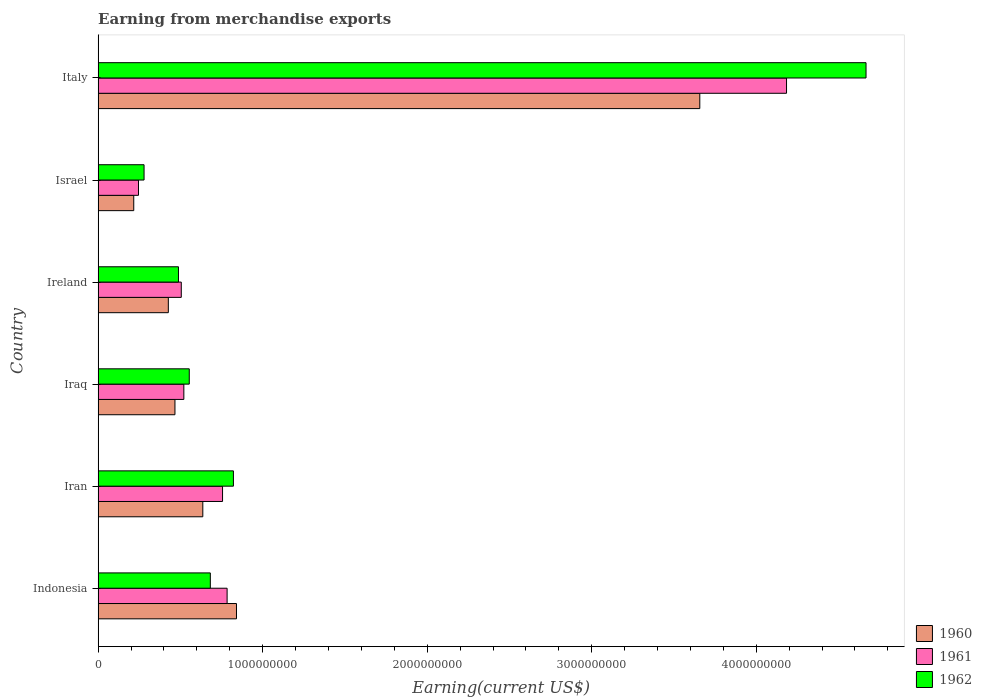How many different coloured bars are there?
Give a very brief answer. 3. How many groups of bars are there?
Your response must be concise. 6. Are the number of bars per tick equal to the number of legend labels?
Provide a succinct answer. Yes. How many bars are there on the 5th tick from the top?
Your answer should be compact. 3. What is the label of the 3rd group of bars from the top?
Keep it short and to the point. Ireland. What is the amount earned from merchandise exports in 1960 in Iran?
Ensure brevity in your answer.  6.36e+08. Across all countries, what is the maximum amount earned from merchandise exports in 1961?
Offer a very short reply. 4.18e+09. Across all countries, what is the minimum amount earned from merchandise exports in 1960?
Give a very brief answer. 2.17e+08. In which country was the amount earned from merchandise exports in 1960 maximum?
Provide a short and direct response. Italy. In which country was the amount earned from merchandise exports in 1962 minimum?
Give a very brief answer. Israel. What is the total amount earned from merchandise exports in 1962 in the graph?
Offer a very short reply. 7.49e+09. What is the difference between the amount earned from merchandise exports in 1962 in Indonesia and that in Israel?
Offer a terse response. 4.03e+08. What is the difference between the amount earned from merchandise exports in 1962 in Iraq and the amount earned from merchandise exports in 1961 in Iran?
Keep it short and to the point. -2.02e+08. What is the average amount earned from merchandise exports in 1961 per country?
Offer a very short reply. 1.17e+09. What is the difference between the amount earned from merchandise exports in 1961 and amount earned from merchandise exports in 1962 in Israel?
Offer a very short reply. -3.39e+07. What is the ratio of the amount earned from merchandise exports in 1960 in Ireland to that in Israel?
Your response must be concise. 1.97. Is the amount earned from merchandise exports in 1960 in Iran less than that in Ireland?
Offer a terse response. No. What is the difference between the highest and the second highest amount earned from merchandise exports in 1962?
Provide a short and direct response. 3.84e+09. What is the difference between the highest and the lowest amount earned from merchandise exports in 1961?
Offer a very short reply. 3.94e+09. In how many countries, is the amount earned from merchandise exports in 1960 greater than the average amount earned from merchandise exports in 1960 taken over all countries?
Provide a succinct answer. 1. What does the 3rd bar from the top in Iraq represents?
Give a very brief answer. 1960. Is it the case that in every country, the sum of the amount earned from merchandise exports in 1961 and amount earned from merchandise exports in 1960 is greater than the amount earned from merchandise exports in 1962?
Offer a very short reply. Yes. How many bars are there?
Ensure brevity in your answer.  18. What is the difference between two consecutive major ticks on the X-axis?
Your answer should be very brief. 1.00e+09. Does the graph contain any zero values?
Keep it short and to the point. No. What is the title of the graph?
Give a very brief answer. Earning from merchandise exports. Does "2002" appear as one of the legend labels in the graph?
Give a very brief answer. No. What is the label or title of the X-axis?
Keep it short and to the point. Earning(current US$). What is the label or title of the Y-axis?
Make the answer very short. Country. What is the Earning(current US$) in 1960 in Indonesia?
Offer a very short reply. 8.41e+08. What is the Earning(current US$) in 1961 in Indonesia?
Your response must be concise. 7.84e+08. What is the Earning(current US$) of 1962 in Indonesia?
Your answer should be very brief. 6.82e+08. What is the Earning(current US$) in 1960 in Iran?
Your response must be concise. 6.36e+08. What is the Earning(current US$) in 1961 in Iran?
Keep it short and to the point. 7.56e+08. What is the Earning(current US$) in 1962 in Iran?
Your response must be concise. 8.22e+08. What is the Earning(current US$) of 1960 in Iraq?
Make the answer very short. 4.67e+08. What is the Earning(current US$) of 1961 in Iraq?
Give a very brief answer. 5.21e+08. What is the Earning(current US$) of 1962 in Iraq?
Ensure brevity in your answer.  5.54e+08. What is the Earning(current US$) in 1960 in Ireland?
Provide a succinct answer. 4.27e+08. What is the Earning(current US$) of 1961 in Ireland?
Offer a very short reply. 5.05e+08. What is the Earning(current US$) of 1962 in Ireland?
Your response must be concise. 4.88e+08. What is the Earning(current US$) in 1960 in Israel?
Your answer should be very brief. 2.17e+08. What is the Earning(current US$) in 1961 in Israel?
Your answer should be compact. 2.45e+08. What is the Earning(current US$) in 1962 in Israel?
Ensure brevity in your answer.  2.79e+08. What is the Earning(current US$) of 1960 in Italy?
Your answer should be compact. 3.66e+09. What is the Earning(current US$) in 1961 in Italy?
Provide a succinct answer. 4.18e+09. What is the Earning(current US$) in 1962 in Italy?
Offer a very short reply. 4.67e+09. Across all countries, what is the maximum Earning(current US$) of 1960?
Offer a very short reply. 3.66e+09. Across all countries, what is the maximum Earning(current US$) of 1961?
Provide a succinct answer. 4.18e+09. Across all countries, what is the maximum Earning(current US$) of 1962?
Offer a very short reply. 4.67e+09. Across all countries, what is the minimum Earning(current US$) in 1960?
Make the answer very short. 2.17e+08. Across all countries, what is the minimum Earning(current US$) in 1961?
Give a very brief answer. 2.45e+08. Across all countries, what is the minimum Earning(current US$) in 1962?
Provide a short and direct response. 2.79e+08. What is the total Earning(current US$) of 1960 in the graph?
Provide a short and direct response. 6.24e+09. What is the total Earning(current US$) of 1961 in the graph?
Offer a very short reply. 7.00e+09. What is the total Earning(current US$) of 1962 in the graph?
Provide a succinct answer. 7.49e+09. What is the difference between the Earning(current US$) in 1960 in Indonesia and that in Iran?
Make the answer very short. 2.05e+08. What is the difference between the Earning(current US$) of 1961 in Indonesia and that in Iran?
Give a very brief answer. 2.77e+07. What is the difference between the Earning(current US$) in 1962 in Indonesia and that in Iran?
Provide a short and direct response. -1.40e+08. What is the difference between the Earning(current US$) of 1960 in Indonesia and that in Iraq?
Provide a short and direct response. 3.74e+08. What is the difference between the Earning(current US$) of 1961 in Indonesia and that in Iraq?
Provide a short and direct response. 2.63e+08. What is the difference between the Earning(current US$) in 1962 in Indonesia and that in Iraq?
Give a very brief answer. 1.28e+08. What is the difference between the Earning(current US$) of 1960 in Indonesia and that in Ireland?
Ensure brevity in your answer.  4.14e+08. What is the difference between the Earning(current US$) of 1961 in Indonesia and that in Ireland?
Make the answer very short. 2.79e+08. What is the difference between the Earning(current US$) of 1962 in Indonesia and that in Ireland?
Your answer should be compact. 1.94e+08. What is the difference between the Earning(current US$) in 1960 in Indonesia and that in Israel?
Make the answer very short. 6.24e+08. What is the difference between the Earning(current US$) in 1961 in Indonesia and that in Israel?
Provide a short and direct response. 5.39e+08. What is the difference between the Earning(current US$) in 1962 in Indonesia and that in Israel?
Your answer should be very brief. 4.03e+08. What is the difference between the Earning(current US$) of 1960 in Indonesia and that in Italy?
Make the answer very short. -2.82e+09. What is the difference between the Earning(current US$) of 1961 in Indonesia and that in Italy?
Offer a very short reply. -3.40e+09. What is the difference between the Earning(current US$) of 1962 in Indonesia and that in Italy?
Your response must be concise. -3.99e+09. What is the difference between the Earning(current US$) in 1960 in Iran and that in Iraq?
Your response must be concise. 1.69e+08. What is the difference between the Earning(current US$) of 1961 in Iran and that in Iraq?
Provide a succinct answer. 2.35e+08. What is the difference between the Earning(current US$) of 1962 in Iran and that in Iraq?
Make the answer very short. 2.68e+08. What is the difference between the Earning(current US$) of 1960 in Iran and that in Ireland?
Provide a short and direct response. 2.10e+08. What is the difference between the Earning(current US$) of 1961 in Iran and that in Ireland?
Your answer should be very brief. 2.51e+08. What is the difference between the Earning(current US$) of 1962 in Iran and that in Ireland?
Offer a very short reply. 3.34e+08. What is the difference between the Earning(current US$) in 1960 in Iran and that in Israel?
Your answer should be very brief. 4.20e+08. What is the difference between the Earning(current US$) of 1961 in Iran and that in Israel?
Give a very brief answer. 5.11e+08. What is the difference between the Earning(current US$) of 1962 in Iran and that in Israel?
Your response must be concise. 5.43e+08. What is the difference between the Earning(current US$) of 1960 in Iran and that in Italy?
Provide a succinct answer. -3.02e+09. What is the difference between the Earning(current US$) in 1961 in Iran and that in Italy?
Make the answer very short. -3.43e+09. What is the difference between the Earning(current US$) in 1962 in Iran and that in Italy?
Your answer should be compact. -3.84e+09. What is the difference between the Earning(current US$) in 1960 in Iraq and that in Ireland?
Ensure brevity in your answer.  4.03e+07. What is the difference between the Earning(current US$) in 1961 in Iraq and that in Ireland?
Give a very brief answer. 1.56e+07. What is the difference between the Earning(current US$) of 1962 in Iraq and that in Ireland?
Offer a terse response. 6.57e+07. What is the difference between the Earning(current US$) of 1960 in Iraq and that in Israel?
Your response must be concise. 2.50e+08. What is the difference between the Earning(current US$) of 1961 in Iraq and that in Israel?
Make the answer very short. 2.76e+08. What is the difference between the Earning(current US$) in 1962 in Iraq and that in Israel?
Your response must be concise. 2.75e+08. What is the difference between the Earning(current US$) in 1960 in Iraq and that in Italy?
Provide a short and direct response. -3.19e+09. What is the difference between the Earning(current US$) of 1961 in Iraq and that in Italy?
Your response must be concise. -3.66e+09. What is the difference between the Earning(current US$) of 1962 in Iraq and that in Italy?
Your answer should be compact. -4.11e+09. What is the difference between the Earning(current US$) of 1960 in Ireland and that in Israel?
Ensure brevity in your answer.  2.10e+08. What is the difference between the Earning(current US$) in 1961 in Ireland and that in Israel?
Keep it short and to the point. 2.60e+08. What is the difference between the Earning(current US$) in 1962 in Ireland and that in Israel?
Provide a succinct answer. 2.09e+08. What is the difference between the Earning(current US$) of 1960 in Ireland and that in Italy?
Keep it short and to the point. -3.23e+09. What is the difference between the Earning(current US$) of 1961 in Ireland and that in Italy?
Your response must be concise. -3.68e+09. What is the difference between the Earning(current US$) in 1962 in Ireland and that in Italy?
Ensure brevity in your answer.  -4.18e+09. What is the difference between the Earning(current US$) of 1960 in Israel and that in Italy?
Provide a succinct answer. -3.44e+09. What is the difference between the Earning(current US$) in 1961 in Israel and that in Italy?
Offer a terse response. -3.94e+09. What is the difference between the Earning(current US$) of 1962 in Israel and that in Italy?
Provide a short and direct response. -4.39e+09. What is the difference between the Earning(current US$) of 1960 in Indonesia and the Earning(current US$) of 1961 in Iran?
Provide a short and direct response. 8.47e+07. What is the difference between the Earning(current US$) of 1960 in Indonesia and the Earning(current US$) of 1962 in Iran?
Provide a succinct answer. 1.86e+07. What is the difference between the Earning(current US$) of 1961 in Indonesia and the Earning(current US$) of 1962 in Iran?
Your answer should be compact. -3.84e+07. What is the difference between the Earning(current US$) in 1960 in Indonesia and the Earning(current US$) in 1961 in Iraq?
Offer a terse response. 3.20e+08. What is the difference between the Earning(current US$) of 1960 in Indonesia and the Earning(current US$) of 1962 in Iraq?
Keep it short and to the point. 2.87e+08. What is the difference between the Earning(current US$) in 1961 in Indonesia and the Earning(current US$) in 1962 in Iraq?
Offer a very short reply. 2.30e+08. What is the difference between the Earning(current US$) in 1960 in Indonesia and the Earning(current US$) in 1961 in Ireland?
Offer a very short reply. 3.36e+08. What is the difference between the Earning(current US$) of 1960 in Indonesia and the Earning(current US$) of 1962 in Ireland?
Your answer should be very brief. 3.53e+08. What is the difference between the Earning(current US$) of 1961 in Indonesia and the Earning(current US$) of 1962 in Ireland?
Provide a short and direct response. 2.96e+08. What is the difference between the Earning(current US$) in 1960 in Indonesia and the Earning(current US$) in 1961 in Israel?
Ensure brevity in your answer.  5.96e+08. What is the difference between the Earning(current US$) of 1960 in Indonesia and the Earning(current US$) of 1962 in Israel?
Provide a short and direct response. 5.62e+08. What is the difference between the Earning(current US$) of 1961 in Indonesia and the Earning(current US$) of 1962 in Israel?
Provide a short and direct response. 5.05e+08. What is the difference between the Earning(current US$) in 1960 in Indonesia and the Earning(current US$) in 1961 in Italy?
Provide a succinct answer. -3.34e+09. What is the difference between the Earning(current US$) of 1960 in Indonesia and the Earning(current US$) of 1962 in Italy?
Offer a terse response. -3.83e+09. What is the difference between the Earning(current US$) of 1961 in Indonesia and the Earning(current US$) of 1962 in Italy?
Your answer should be very brief. -3.88e+09. What is the difference between the Earning(current US$) of 1960 in Iran and the Earning(current US$) of 1961 in Iraq?
Your answer should be very brief. 1.15e+08. What is the difference between the Earning(current US$) of 1960 in Iran and the Earning(current US$) of 1962 in Iraq?
Your answer should be very brief. 8.23e+07. What is the difference between the Earning(current US$) of 1961 in Iran and the Earning(current US$) of 1962 in Iraq?
Your answer should be very brief. 2.02e+08. What is the difference between the Earning(current US$) of 1960 in Iran and the Earning(current US$) of 1961 in Ireland?
Make the answer very short. 1.31e+08. What is the difference between the Earning(current US$) of 1960 in Iran and the Earning(current US$) of 1962 in Ireland?
Provide a succinct answer. 1.48e+08. What is the difference between the Earning(current US$) of 1961 in Iran and the Earning(current US$) of 1962 in Ireland?
Your answer should be very brief. 2.68e+08. What is the difference between the Earning(current US$) in 1960 in Iran and the Earning(current US$) in 1961 in Israel?
Give a very brief answer. 3.91e+08. What is the difference between the Earning(current US$) in 1960 in Iran and the Earning(current US$) in 1962 in Israel?
Make the answer very short. 3.57e+08. What is the difference between the Earning(current US$) of 1961 in Iran and the Earning(current US$) of 1962 in Israel?
Ensure brevity in your answer.  4.77e+08. What is the difference between the Earning(current US$) of 1960 in Iran and the Earning(current US$) of 1961 in Italy?
Ensure brevity in your answer.  -3.55e+09. What is the difference between the Earning(current US$) of 1960 in Iran and the Earning(current US$) of 1962 in Italy?
Your response must be concise. -4.03e+09. What is the difference between the Earning(current US$) of 1961 in Iran and the Earning(current US$) of 1962 in Italy?
Give a very brief answer. -3.91e+09. What is the difference between the Earning(current US$) of 1960 in Iraq and the Earning(current US$) of 1961 in Ireland?
Your answer should be compact. -3.84e+07. What is the difference between the Earning(current US$) in 1960 in Iraq and the Earning(current US$) in 1962 in Ireland?
Provide a succinct answer. -2.13e+07. What is the difference between the Earning(current US$) in 1961 in Iraq and the Earning(current US$) in 1962 in Ireland?
Give a very brief answer. 3.27e+07. What is the difference between the Earning(current US$) of 1960 in Iraq and the Earning(current US$) of 1961 in Israel?
Provide a succinct answer. 2.22e+08. What is the difference between the Earning(current US$) of 1960 in Iraq and the Earning(current US$) of 1962 in Israel?
Your answer should be compact. 1.88e+08. What is the difference between the Earning(current US$) of 1961 in Iraq and the Earning(current US$) of 1962 in Israel?
Keep it short and to the point. 2.42e+08. What is the difference between the Earning(current US$) of 1960 in Iraq and the Earning(current US$) of 1961 in Italy?
Provide a succinct answer. -3.72e+09. What is the difference between the Earning(current US$) of 1960 in Iraq and the Earning(current US$) of 1962 in Italy?
Your answer should be very brief. -4.20e+09. What is the difference between the Earning(current US$) in 1961 in Iraq and the Earning(current US$) in 1962 in Italy?
Provide a short and direct response. -4.15e+09. What is the difference between the Earning(current US$) in 1960 in Ireland and the Earning(current US$) in 1961 in Israel?
Provide a succinct answer. 1.81e+08. What is the difference between the Earning(current US$) in 1960 in Ireland and the Earning(current US$) in 1962 in Israel?
Provide a short and direct response. 1.48e+08. What is the difference between the Earning(current US$) in 1961 in Ireland and the Earning(current US$) in 1962 in Israel?
Offer a very short reply. 2.26e+08. What is the difference between the Earning(current US$) in 1960 in Ireland and the Earning(current US$) in 1961 in Italy?
Offer a terse response. -3.76e+09. What is the difference between the Earning(current US$) of 1960 in Ireland and the Earning(current US$) of 1962 in Italy?
Give a very brief answer. -4.24e+09. What is the difference between the Earning(current US$) in 1961 in Ireland and the Earning(current US$) in 1962 in Italy?
Your response must be concise. -4.16e+09. What is the difference between the Earning(current US$) in 1960 in Israel and the Earning(current US$) in 1961 in Italy?
Provide a succinct answer. -3.97e+09. What is the difference between the Earning(current US$) of 1960 in Israel and the Earning(current US$) of 1962 in Italy?
Your answer should be compact. -4.45e+09. What is the difference between the Earning(current US$) in 1961 in Israel and the Earning(current US$) in 1962 in Italy?
Ensure brevity in your answer.  -4.42e+09. What is the average Earning(current US$) of 1960 per country?
Give a very brief answer. 1.04e+09. What is the average Earning(current US$) of 1961 per country?
Ensure brevity in your answer.  1.17e+09. What is the average Earning(current US$) in 1962 per country?
Ensure brevity in your answer.  1.25e+09. What is the difference between the Earning(current US$) in 1960 and Earning(current US$) in 1961 in Indonesia?
Provide a succinct answer. 5.70e+07. What is the difference between the Earning(current US$) of 1960 and Earning(current US$) of 1962 in Indonesia?
Provide a succinct answer. 1.59e+08. What is the difference between the Earning(current US$) in 1961 and Earning(current US$) in 1962 in Indonesia?
Keep it short and to the point. 1.02e+08. What is the difference between the Earning(current US$) of 1960 and Earning(current US$) of 1961 in Iran?
Give a very brief answer. -1.20e+08. What is the difference between the Earning(current US$) of 1960 and Earning(current US$) of 1962 in Iran?
Offer a very short reply. -1.86e+08. What is the difference between the Earning(current US$) of 1961 and Earning(current US$) of 1962 in Iran?
Your answer should be compact. -6.61e+07. What is the difference between the Earning(current US$) of 1960 and Earning(current US$) of 1961 in Iraq?
Your answer should be very brief. -5.40e+07. What is the difference between the Earning(current US$) in 1960 and Earning(current US$) in 1962 in Iraq?
Keep it short and to the point. -8.70e+07. What is the difference between the Earning(current US$) in 1961 and Earning(current US$) in 1962 in Iraq?
Provide a short and direct response. -3.30e+07. What is the difference between the Earning(current US$) in 1960 and Earning(current US$) in 1961 in Ireland?
Keep it short and to the point. -7.87e+07. What is the difference between the Earning(current US$) of 1960 and Earning(current US$) of 1962 in Ireland?
Your response must be concise. -6.16e+07. What is the difference between the Earning(current US$) in 1961 and Earning(current US$) in 1962 in Ireland?
Provide a short and direct response. 1.71e+07. What is the difference between the Earning(current US$) in 1960 and Earning(current US$) in 1961 in Israel?
Ensure brevity in your answer.  -2.87e+07. What is the difference between the Earning(current US$) in 1960 and Earning(current US$) in 1962 in Israel?
Make the answer very short. -6.26e+07. What is the difference between the Earning(current US$) of 1961 and Earning(current US$) of 1962 in Israel?
Give a very brief answer. -3.39e+07. What is the difference between the Earning(current US$) of 1960 and Earning(current US$) of 1961 in Italy?
Provide a short and direct response. -5.27e+08. What is the difference between the Earning(current US$) of 1960 and Earning(current US$) of 1962 in Italy?
Keep it short and to the point. -1.01e+09. What is the difference between the Earning(current US$) in 1961 and Earning(current US$) in 1962 in Italy?
Your answer should be very brief. -4.83e+08. What is the ratio of the Earning(current US$) in 1960 in Indonesia to that in Iran?
Give a very brief answer. 1.32. What is the ratio of the Earning(current US$) in 1961 in Indonesia to that in Iran?
Provide a short and direct response. 1.04. What is the ratio of the Earning(current US$) of 1962 in Indonesia to that in Iran?
Keep it short and to the point. 0.83. What is the ratio of the Earning(current US$) of 1960 in Indonesia to that in Iraq?
Give a very brief answer. 1.8. What is the ratio of the Earning(current US$) in 1961 in Indonesia to that in Iraq?
Make the answer very short. 1.5. What is the ratio of the Earning(current US$) of 1962 in Indonesia to that in Iraq?
Offer a very short reply. 1.23. What is the ratio of the Earning(current US$) of 1960 in Indonesia to that in Ireland?
Your answer should be compact. 1.97. What is the ratio of the Earning(current US$) in 1961 in Indonesia to that in Ireland?
Your answer should be compact. 1.55. What is the ratio of the Earning(current US$) in 1962 in Indonesia to that in Ireland?
Make the answer very short. 1.4. What is the ratio of the Earning(current US$) of 1960 in Indonesia to that in Israel?
Your answer should be very brief. 3.88. What is the ratio of the Earning(current US$) of 1961 in Indonesia to that in Israel?
Your answer should be compact. 3.2. What is the ratio of the Earning(current US$) of 1962 in Indonesia to that in Israel?
Keep it short and to the point. 2.44. What is the ratio of the Earning(current US$) in 1960 in Indonesia to that in Italy?
Your answer should be very brief. 0.23. What is the ratio of the Earning(current US$) in 1961 in Indonesia to that in Italy?
Offer a terse response. 0.19. What is the ratio of the Earning(current US$) of 1962 in Indonesia to that in Italy?
Your response must be concise. 0.15. What is the ratio of the Earning(current US$) of 1960 in Iran to that in Iraq?
Your response must be concise. 1.36. What is the ratio of the Earning(current US$) in 1961 in Iran to that in Iraq?
Provide a succinct answer. 1.45. What is the ratio of the Earning(current US$) in 1962 in Iran to that in Iraq?
Provide a succinct answer. 1.48. What is the ratio of the Earning(current US$) in 1960 in Iran to that in Ireland?
Your response must be concise. 1.49. What is the ratio of the Earning(current US$) of 1961 in Iran to that in Ireland?
Provide a succinct answer. 1.5. What is the ratio of the Earning(current US$) in 1962 in Iran to that in Ireland?
Your answer should be compact. 1.68. What is the ratio of the Earning(current US$) of 1960 in Iran to that in Israel?
Your answer should be compact. 2.94. What is the ratio of the Earning(current US$) of 1961 in Iran to that in Israel?
Keep it short and to the point. 3.08. What is the ratio of the Earning(current US$) of 1962 in Iran to that in Israel?
Ensure brevity in your answer.  2.95. What is the ratio of the Earning(current US$) in 1960 in Iran to that in Italy?
Provide a succinct answer. 0.17. What is the ratio of the Earning(current US$) of 1961 in Iran to that in Italy?
Your response must be concise. 0.18. What is the ratio of the Earning(current US$) of 1962 in Iran to that in Italy?
Make the answer very short. 0.18. What is the ratio of the Earning(current US$) in 1960 in Iraq to that in Ireland?
Ensure brevity in your answer.  1.09. What is the ratio of the Earning(current US$) in 1961 in Iraq to that in Ireland?
Your answer should be compact. 1.03. What is the ratio of the Earning(current US$) of 1962 in Iraq to that in Ireland?
Give a very brief answer. 1.13. What is the ratio of the Earning(current US$) of 1960 in Iraq to that in Israel?
Give a very brief answer. 2.16. What is the ratio of the Earning(current US$) in 1961 in Iraq to that in Israel?
Ensure brevity in your answer.  2.12. What is the ratio of the Earning(current US$) in 1962 in Iraq to that in Israel?
Your answer should be compact. 1.98. What is the ratio of the Earning(current US$) in 1960 in Iraq to that in Italy?
Offer a terse response. 0.13. What is the ratio of the Earning(current US$) of 1961 in Iraq to that in Italy?
Give a very brief answer. 0.12. What is the ratio of the Earning(current US$) in 1962 in Iraq to that in Italy?
Offer a very short reply. 0.12. What is the ratio of the Earning(current US$) of 1960 in Ireland to that in Israel?
Your answer should be compact. 1.97. What is the ratio of the Earning(current US$) in 1961 in Ireland to that in Israel?
Your answer should be compact. 2.06. What is the ratio of the Earning(current US$) of 1962 in Ireland to that in Israel?
Ensure brevity in your answer.  1.75. What is the ratio of the Earning(current US$) of 1960 in Ireland to that in Italy?
Your answer should be very brief. 0.12. What is the ratio of the Earning(current US$) of 1961 in Ireland to that in Italy?
Ensure brevity in your answer.  0.12. What is the ratio of the Earning(current US$) in 1962 in Ireland to that in Italy?
Give a very brief answer. 0.1. What is the ratio of the Earning(current US$) of 1960 in Israel to that in Italy?
Keep it short and to the point. 0.06. What is the ratio of the Earning(current US$) of 1961 in Israel to that in Italy?
Your response must be concise. 0.06. What is the ratio of the Earning(current US$) of 1962 in Israel to that in Italy?
Make the answer very short. 0.06. What is the difference between the highest and the second highest Earning(current US$) in 1960?
Provide a short and direct response. 2.82e+09. What is the difference between the highest and the second highest Earning(current US$) of 1961?
Keep it short and to the point. 3.40e+09. What is the difference between the highest and the second highest Earning(current US$) in 1962?
Give a very brief answer. 3.84e+09. What is the difference between the highest and the lowest Earning(current US$) in 1960?
Your answer should be compact. 3.44e+09. What is the difference between the highest and the lowest Earning(current US$) of 1961?
Provide a succinct answer. 3.94e+09. What is the difference between the highest and the lowest Earning(current US$) of 1962?
Offer a very short reply. 4.39e+09. 